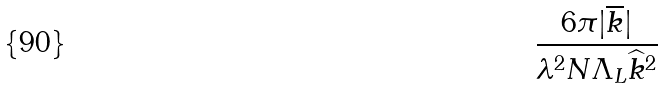Convert formula to latex. <formula><loc_0><loc_0><loc_500><loc_500>\frac { 6 \pi | \overline { k } | } { \lambda ^ { 2 } N \Lambda _ { L } \widehat { k } ^ { 2 } }</formula> 